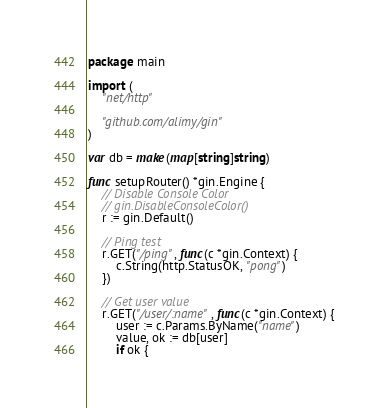<code> <loc_0><loc_0><loc_500><loc_500><_Go_>package main

import (
	"net/http"

	"github.com/alimy/gin"
)

var db = make(map[string]string)

func setupRouter() *gin.Engine {
	// Disable Console Color
	// gin.DisableConsoleColor()
	r := gin.Default()

	// Ping test
	r.GET("/ping", func(c *gin.Context) {
		c.String(http.StatusOK, "pong")
	})

	// Get user value
	r.GET("/user/:name", func(c *gin.Context) {
		user := c.Params.ByName("name")
		value, ok := db[user]
		if ok {</code> 